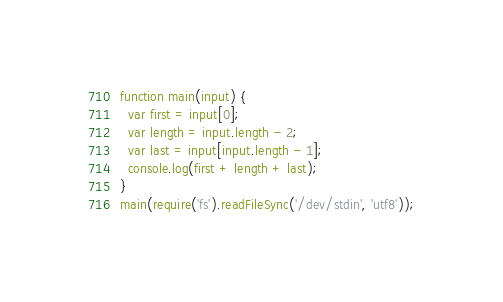Convert code to text. <code><loc_0><loc_0><loc_500><loc_500><_JavaScript_>function main(input) {
  var first = input[0];
  var length = input.length - 2;
  var last = input[input.length - 1];
  console.log(first + length + last);
}
main(require('fs').readFileSync('/dev/stdin', 'utf8'));</code> 